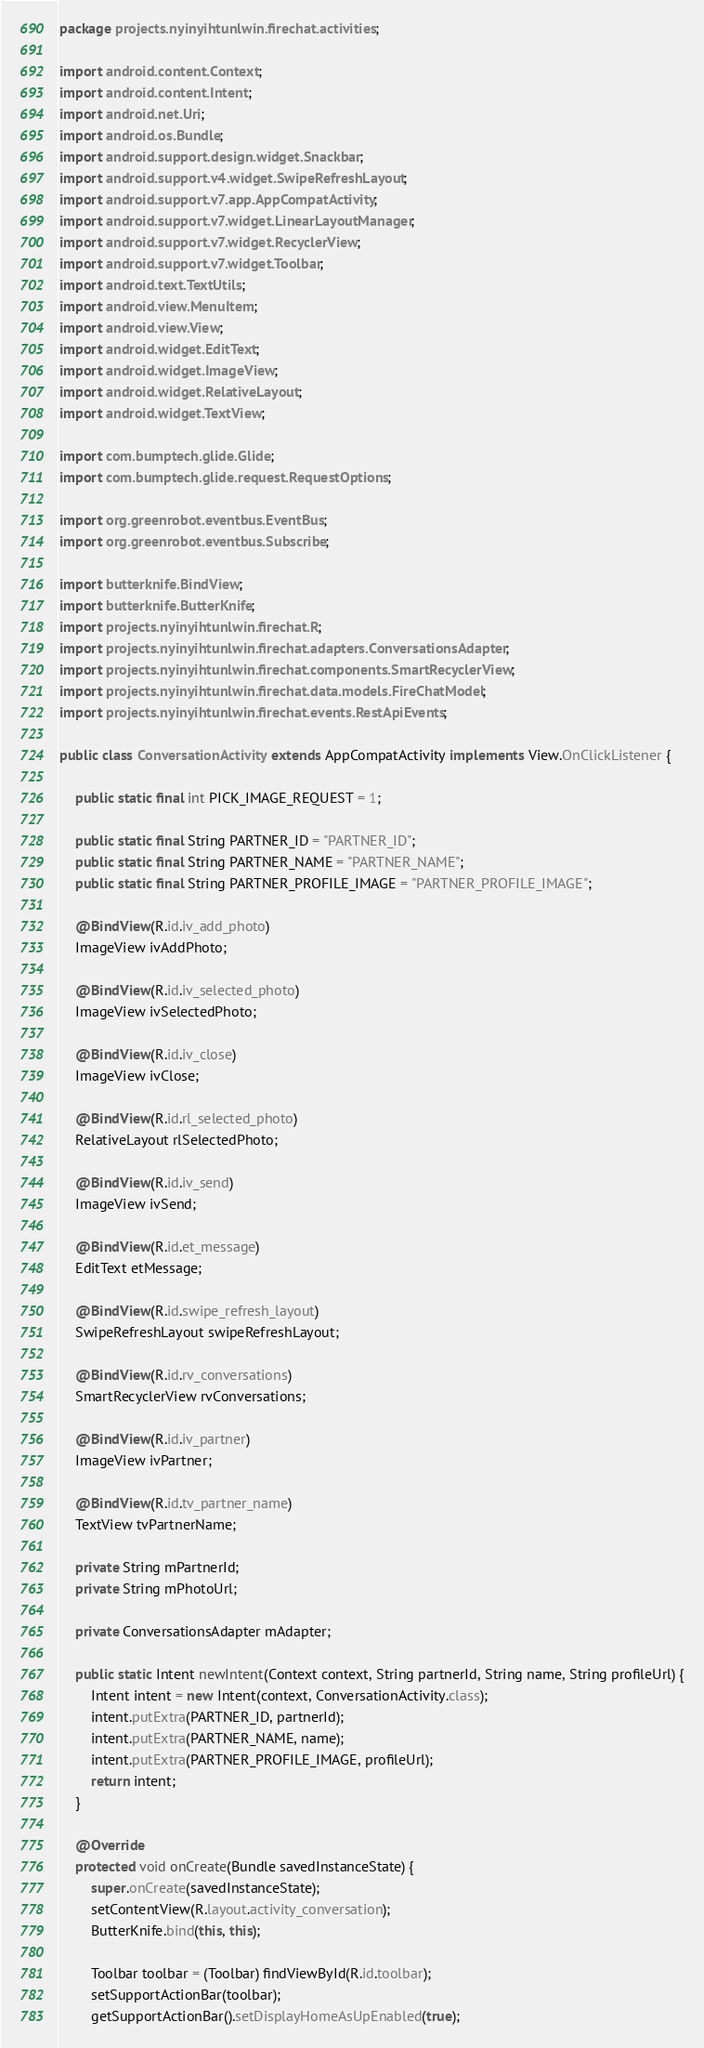Convert code to text. <code><loc_0><loc_0><loc_500><loc_500><_Java_>package projects.nyinyihtunlwin.firechat.activities;

import android.content.Context;
import android.content.Intent;
import android.net.Uri;
import android.os.Bundle;
import android.support.design.widget.Snackbar;
import android.support.v4.widget.SwipeRefreshLayout;
import android.support.v7.app.AppCompatActivity;
import android.support.v7.widget.LinearLayoutManager;
import android.support.v7.widget.RecyclerView;
import android.support.v7.widget.Toolbar;
import android.text.TextUtils;
import android.view.MenuItem;
import android.view.View;
import android.widget.EditText;
import android.widget.ImageView;
import android.widget.RelativeLayout;
import android.widget.TextView;

import com.bumptech.glide.Glide;
import com.bumptech.glide.request.RequestOptions;

import org.greenrobot.eventbus.EventBus;
import org.greenrobot.eventbus.Subscribe;

import butterknife.BindView;
import butterknife.ButterKnife;
import projects.nyinyihtunlwin.firechat.R;
import projects.nyinyihtunlwin.firechat.adapters.ConversationsAdapter;
import projects.nyinyihtunlwin.firechat.components.SmartRecyclerView;
import projects.nyinyihtunlwin.firechat.data.models.FireChatModel;
import projects.nyinyihtunlwin.firechat.events.RestApiEvents;

public class ConversationActivity extends AppCompatActivity implements View.OnClickListener {

    public static final int PICK_IMAGE_REQUEST = 1;

    public static final String PARTNER_ID = "PARTNER_ID";
    public static final String PARTNER_NAME = "PARTNER_NAME";
    public static final String PARTNER_PROFILE_IMAGE = "PARTNER_PROFILE_IMAGE";

    @BindView(R.id.iv_add_photo)
    ImageView ivAddPhoto;

    @BindView(R.id.iv_selected_photo)
    ImageView ivSelectedPhoto;

    @BindView(R.id.iv_close)
    ImageView ivClose;

    @BindView(R.id.rl_selected_photo)
    RelativeLayout rlSelectedPhoto;

    @BindView(R.id.iv_send)
    ImageView ivSend;

    @BindView(R.id.et_message)
    EditText etMessage;

    @BindView(R.id.swipe_refresh_layout)
    SwipeRefreshLayout swipeRefreshLayout;

    @BindView(R.id.rv_conversations)
    SmartRecyclerView rvConversations;

    @BindView(R.id.iv_partner)
    ImageView ivPartner;

    @BindView(R.id.tv_partner_name)
    TextView tvPartnerName;

    private String mPartnerId;
    private String mPhotoUrl;

    private ConversationsAdapter mAdapter;

    public static Intent newIntent(Context context, String partnerId, String name, String profileUrl) {
        Intent intent = new Intent(context, ConversationActivity.class);
        intent.putExtra(PARTNER_ID, partnerId);
        intent.putExtra(PARTNER_NAME, name);
        intent.putExtra(PARTNER_PROFILE_IMAGE, profileUrl);
        return intent;
    }

    @Override
    protected void onCreate(Bundle savedInstanceState) {
        super.onCreate(savedInstanceState);
        setContentView(R.layout.activity_conversation);
        ButterKnife.bind(this, this);

        Toolbar toolbar = (Toolbar) findViewById(R.id.toolbar);
        setSupportActionBar(toolbar);
        getSupportActionBar().setDisplayHomeAsUpEnabled(true);
</code> 